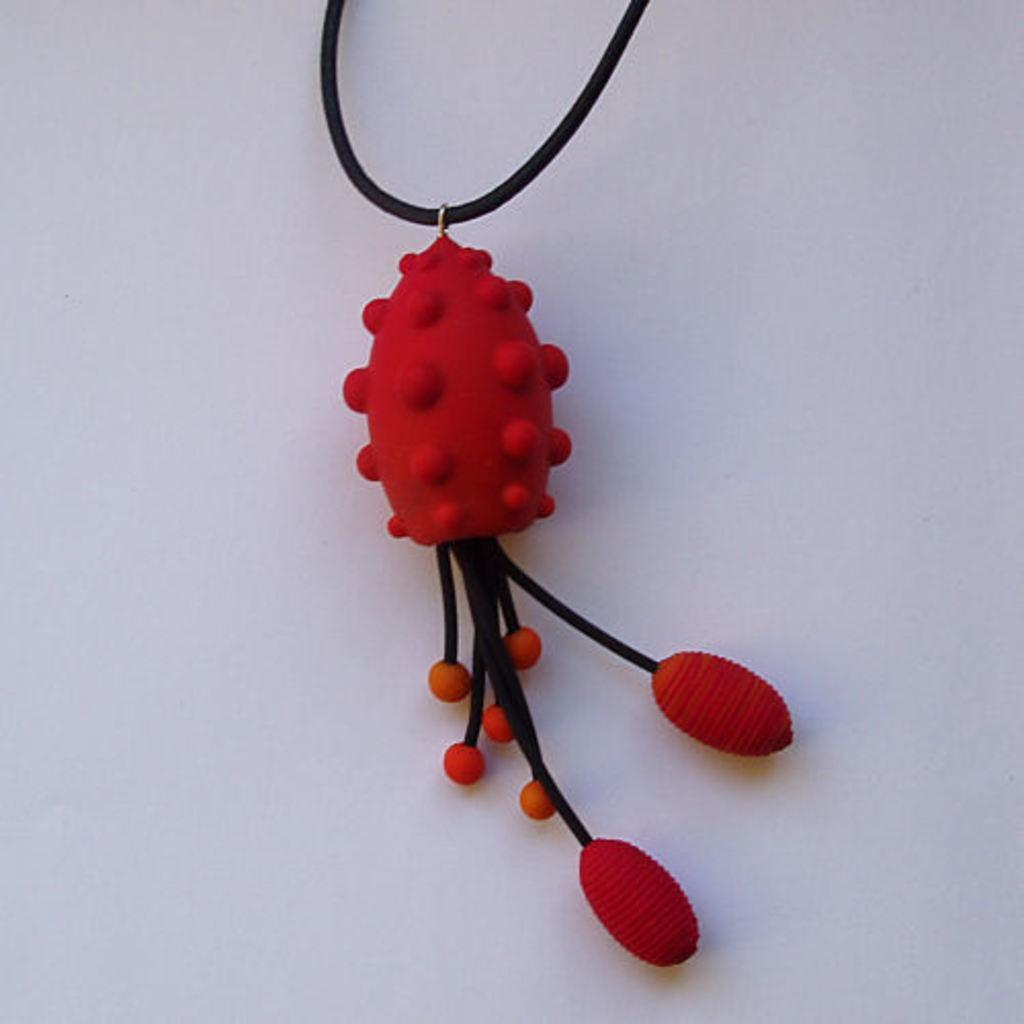What is the main object in the image? There is a locket in the image. Can you describe the background in the image? There is a background in the image, but its specific details are not mentioned in the provided facts. How does the locket feel about its crush in the image? There is no information about a crush or any emotions related to the locket in the image. 